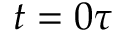Convert formula to latex. <formula><loc_0><loc_0><loc_500><loc_500>t = 0 \tau</formula> 